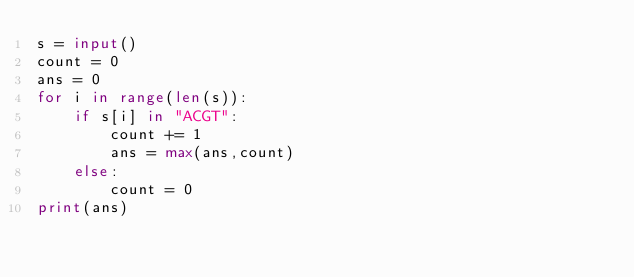<code> <loc_0><loc_0><loc_500><loc_500><_Python_>s = input()
count = 0
ans = 0
for i in range(len(s)):
    if s[i] in "ACGT":
        count += 1
        ans = max(ans,count)
    else:
        count = 0
print(ans)</code> 